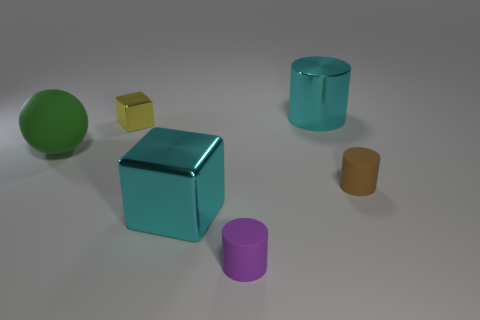What number of brown objects are metal balls or large spheres?
Your answer should be very brief. 0. What is the size of the metallic thing behind the cube that is behind the large green matte sphere?
Your answer should be compact. Large. There is a matte ball; is its color the same as the shiny cube behind the green matte object?
Provide a short and direct response. No. What shape is the big cyan object that is the same material as the cyan block?
Offer a terse response. Cylinder. Is there any other thing of the same color as the matte ball?
Ensure brevity in your answer.  No. There is a object that is the same color as the metal cylinder; what is its size?
Give a very brief answer. Large. Are there more green rubber balls in front of the large rubber sphere than matte cylinders?
Offer a terse response. No. Is the shape of the tiny purple object the same as the shiny object in front of the tiny brown object?
Provide a short and direct response. No. What number of cyan shiny cylinders are the same size as the purple thing?
Ensure brevity in your answer.  0. How many big rubber things are in front of the cyan thing that is in front of the tiny thing to the right of the purple rubber cylinder?
Provide a short and direct response. 0. 